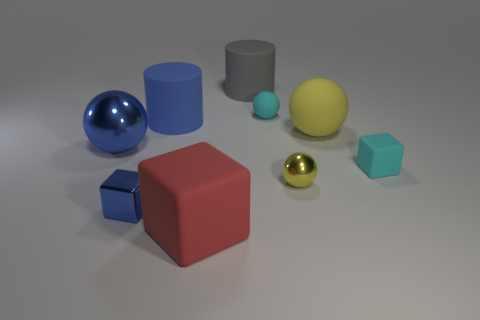Subtract 1 balls. How many balls are left? 3 Subtract all red balls. Subtract all purple cylinders. How many balls are left? 4 Add 1 large blue metallic things. How many objects exist? 10 Subtract all cylinders. How many objects are left? 7 Add 2 cyan matte objects. How many cyan matte objects exist? 4 Subtract 0 yellow cubes. How many objects are left? 9 Subtract all big brown shiny blocks. Subtract all small blue cubes. How many objects are left? 8 Add 2 small cyan matte cubes. How many small cyan matte cubes are left? 3 